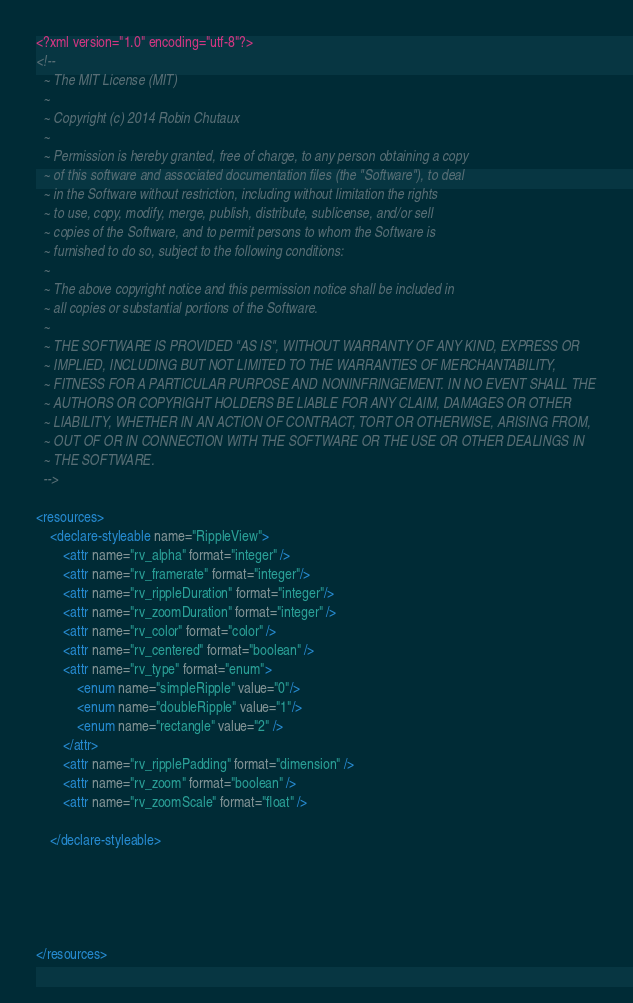<code> <loc_0><loc_0><loc_500><loc_500><_XML_><?xml version="1.0" encoding="utf-8"?>
<!--
  ~ The MIT License (MIT)
  ~
  ~ Copyright (c) 2014 Robin Chutaux
  ~
  ~ Permission is hereby granted, free of charge, to any person obtaining a copy
  ~ of this software and associated documentation files (the "Software"), to deal
  ~ in the Software without restriction, including without limitation the rights
  ~ to use, copy, modify, merge, publish, distribute, sublicense, and/or sell
  ~ copies of the Software, and to permit persons to whom the Software is
  ~ furnished to do so, subject to the following conditions:
  ~
  ~ The above copyright notice and this permission notice shall be included in
  ~ all copies or substantial portions of the Software.
  ~
  ~ THE SOFTWARE IS PROVIDED "AS IS", WITHOUT WARRANTY OF ANY KIND, EXPRESS OR
  ~ IMPLIED, INCLUDING BUT NOT LIMITED TO THE WARRANTIES OF MERCHANTABILITY,
  ~ FITNESS FOR A PARTICULAR PURPOSE AND NONINFRINGEMENT. IN NO EVENT SHALL THE
  ~ AUTHORS OR COPYRIGHT HOLDERS BE LIABLE FOR ANY CLAIM, DAMAGES OR OTHER
  ~ LIABILITY, WHETHER IN AN ACTION OF CONTRACT, TORT OR OTHERWISE, ARISING FROM,
  ~ OUT OF OR IN CONNECTION WITH THE SOFTWARE OR THE USE OR OTHER DEALINGS IN
  ~ THE SOFTWARE.
  -->

<resources>
    <declare-styleable name="RippleView">
        <attr name="rv_alpha" format="integer" />
        <attr name="rv_framerate" format="integer"/>
        <attr name="rv_rippleDuration" format="integer"/>
        <attr name="rv_zoomDuration" format="integer" />
        <attr name="rv_color" format="color" />
        <attr name="rv_centered" format="boolean" />
        <attr name="rv_type" format="enum">
            <enum name="simpleRipple" value="0"/>
            <enum name="doubleRipple" value="1"/>
            <enum name="rectangle" value="2" />
        </attr>
        <attr name="rv_ripplePadding" format="dimension" />
        <attr name="rv_zoom" format="boolean" />
        <attr name="rv_zoomScale" format="float" />

    </declare-styleable>





</resources></code> 